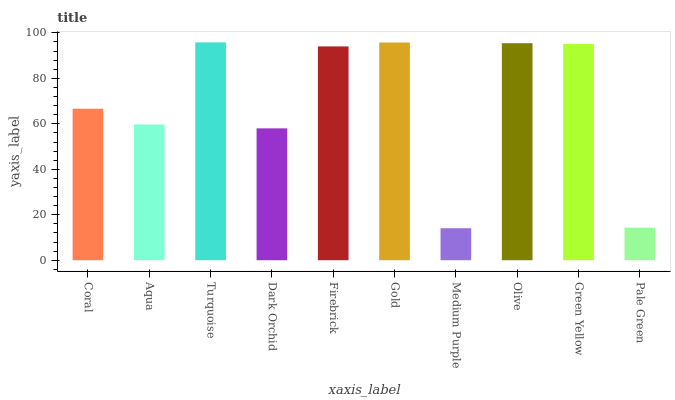Is Medium Purple the minimum?
Answer yes or no. Yes. Is Turquoise the maximum?
Answer yes or no. Yes. Is Aqua the minimum?
Answer yes or no. No. Is Aqua the maximum?
Answer yes or no. No. Is Coral greater than Aqua?
Answer yes or no. Yes. Is Aqua less than Coral?
Answer yes or no. Yes. Is Aqua greater than Coral?
Answer yes or no. No. Is Coral less than Aqua?
Answer yes or no. No. Is Firebrick the high median?
Answer yes or no. Yes. Is Coral the low median?
Answer yes or no. Yes. Is Green Yellow the high median?
Answer yes or no. No. Is Pale Green the low median?
Answer yes or no. No. 